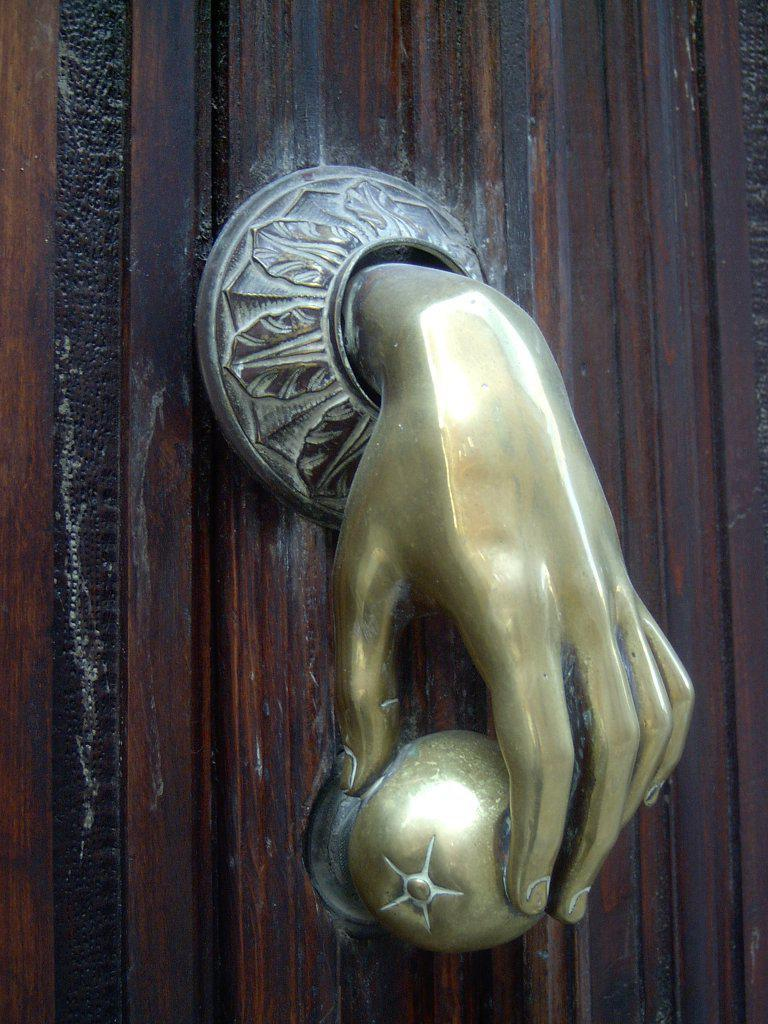What is a prominent feature in the image? There is a door in the image. What part of the door is used for opening and closing it? There is a handle on the door. How many cows can be seen grazing in the image? There are no cows present in the image; it only features a door with a handle. What type of button is used to control the door in the image? There is no button present in the image; the door is operated using the handle. 